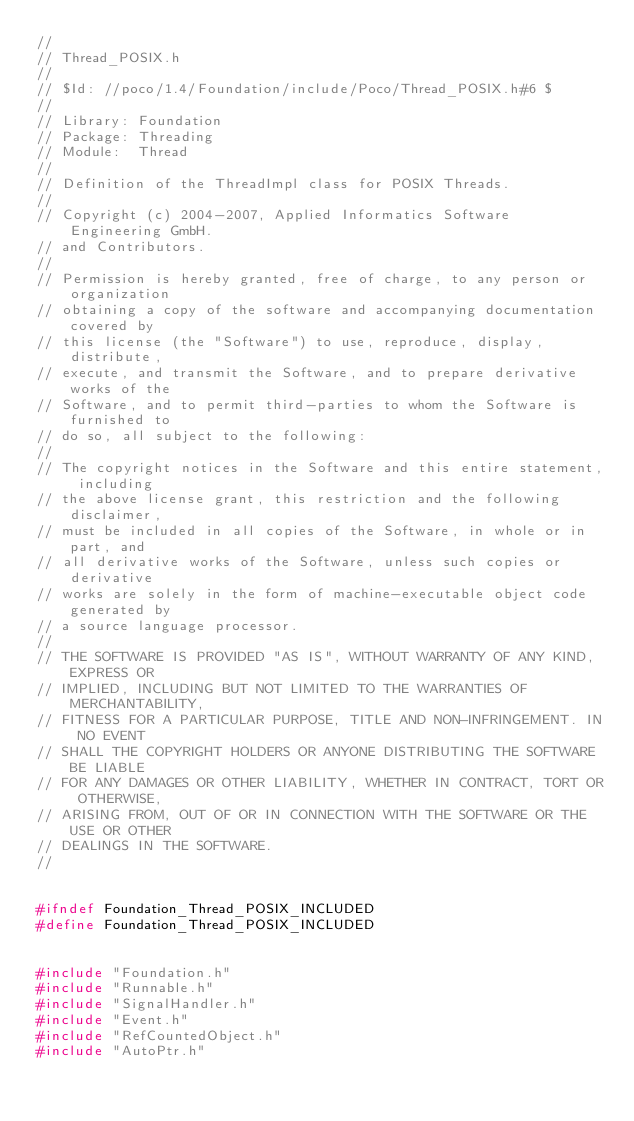Convert code to text. <code><loc_0><loc_0><loc_500><loc_500><_C_>//
// Thread_POSIX.h
//
// $Id: //poco/1.4/Foundation/include/Poco/Thread_POSIX.h#6 $
//
// Library: Foundation
// Package: Threading
// Module:  Thread
//
// Definition of the ThreadImpl class for POSIX Threads.
//
// Copyright (c) 2004-2007, Applied Informatics Software Engineering GmbH.
// and Contributors.
//
// Permission is hereby granted, free of charge, to any person or organization
// obtaining a copy of the software and accompanying documentation covered by
// this license (the "Software") to use, reproduce, display, distribute,
// execute, and transmit the Software, and to prepare derivative works of the
// Software, and to permit third-parties to whom the Software is furnished to
// do so, all subject to the following:
// 
// The copyright notices in the Software and this entire statement, including
// the above license grant, this restriction and the following disclaimer,
// must be included in all copies of the Software, in whole or in part, and
// all derivative works of the Software, unless such copies or derivative
// works are solely in the form of machine-executable object code generated by
// a source language processor.
// 
// THE SOFTWARE IS PROVIDED "AS IS", WITHOUT WARRANTY OF ANY KIND, EXPRESS OR
// IMPLIED, INCLUDING BUT NOT LIMITED TO THE WARRANTIES OF MERCHANTABILITY,
// FITNESS FOR A PARTICULAR PURPOSE, TITLE AND NON-INFRINGEMENT. IN NO EVENT
// SHALL THE COPYRIGHT HOLDERS OR ANYONE DISTRIBUTING THE SOFTWARE BE LIABLE
// FOR ANY DAMAGES OR OTHER LIABILITY, WHETHER IN CONTRACT, TORT OR OTHERWISE,
// ARISING FROM, OUT OF OR IN CONNECTION WITH THE SOFTWARE OR THE USE OR OTHER
// DEALINGS IN THE SOFTWARE.
//


#ifndef Foundation_Thread_POSIX_INCLUDED
#define Foundation_Thread_POSIX_INCLUDED


#include "Foundation.h"
#include "Runnable.h"
#include "SignalHandler.h"
#include "Event.h"
#include "RefCountedObject.h"
#include "AutoPtr.h"</code> 